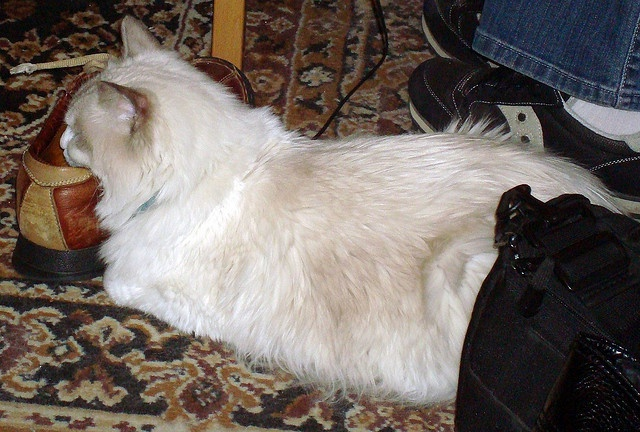Describe the objects in this image and their specific colors. I can see cat in black, lightgray, and darkgray tones, handbag in black, gray, and darkgray tones, and people in black, navy, darkgray, and gray tones in this image. 